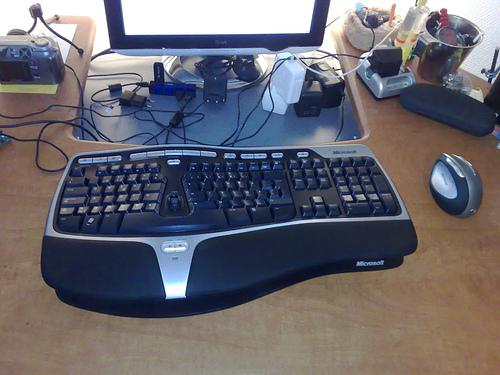Question: where are the wires to computer keyboard?
Choices:
A. Over keyboard.
B. Framing computer.
C. Invisible.
D. Under monitor.
Answer with the letter. Answer: D Question: what color does the keyboard appear to be primarily?
Choices:
A. White.
B. Pink.
C. Red and grey.
D. Dark blue.
Answer with the letter. Answer: D 